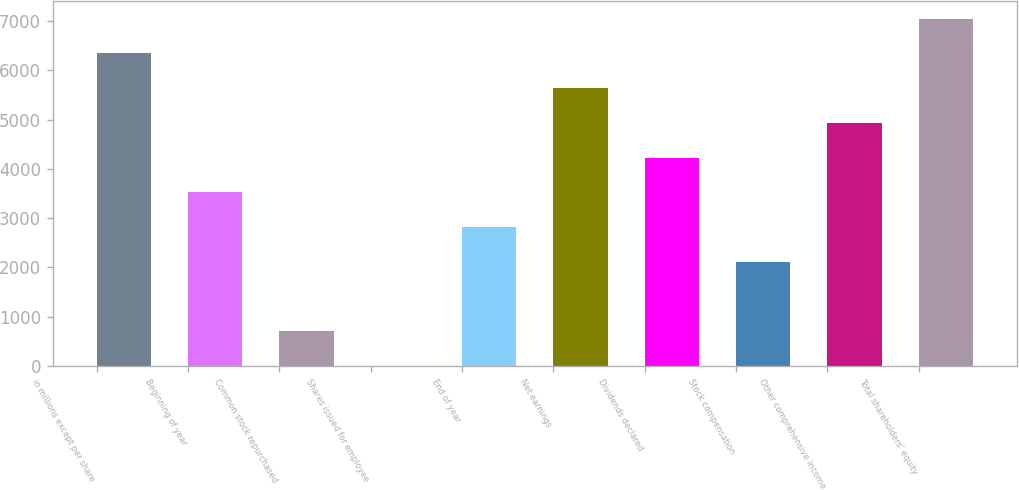<chart> <loc_0><loc_0><loc_500><loc_500><bar_chart><fcel>in millions except per share<fcel>Beginning of year<fcel>Common stock repurchased<fcel>Shares issued for employee<fcel>End of year<fcel>Net earnings<fcel>Dividends declared<fcel>Stock compensation<fcel>Other comprehensive income<fcel>Total shareholders' equity<nl><fcel>6343.3<fcel>3524.5<fcel>705.7<fcel>1<fcel>2819.8<fcel>5638.6<fcel>4229.2<fcel>2115.1<fcel>4933.9<fcel>7048<nl></chart> 